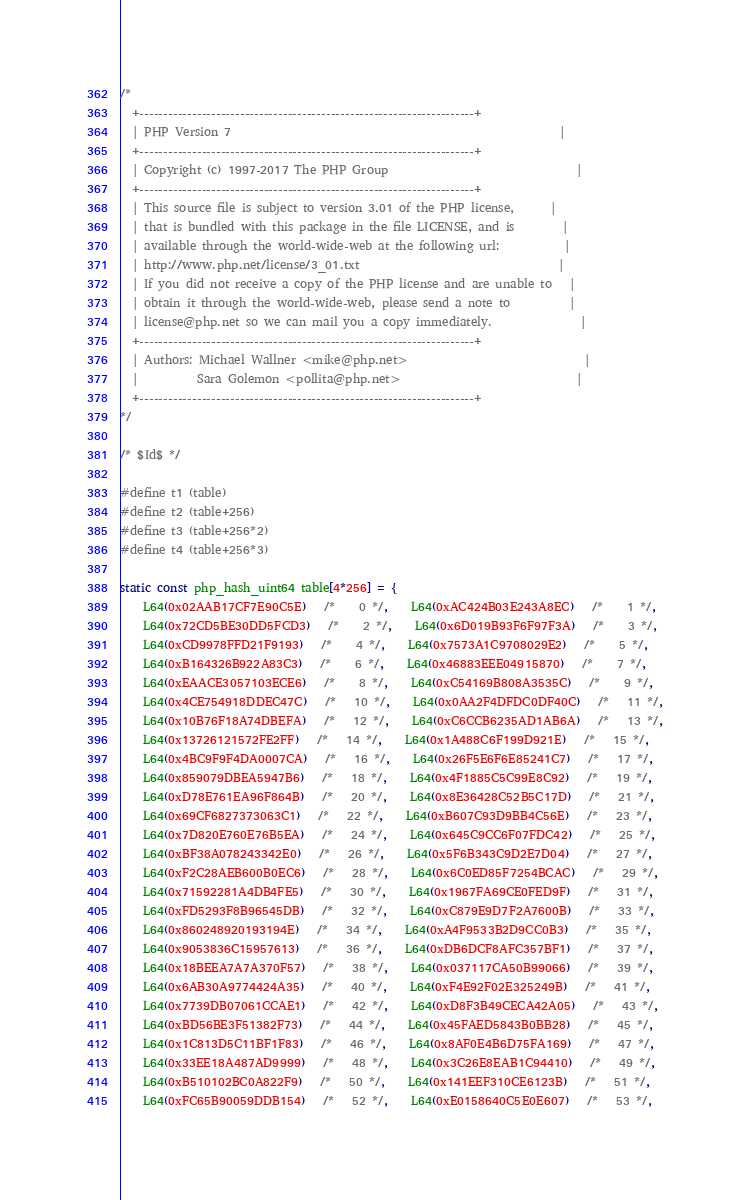Convert code to text. <code><loc_0><loc_0><loc_500><loc_500><_C_>/*
  +----------------------------------------------------------------------+
  | PHP Version 7                                                        |
  +----------------------------------------------------------------------+
  | Copyright (c) 1997-2017 The PHP Group                                |
  +----------------------------------------------------------------------+
  | This source file is subject to version 3.01 of the PHP license,      |
  | that is bundled with this package in the file LICENSE, and is        |
  | available through the world-wide-web at the following url:           |
  | http://www.php.net/license/3_01.txt                                  |
  | If you did not receive a copy of the PHP license and are unable to   |
  | obtain it through the world-wide-web, please send a note to          |
  | license@php.net so we can mail you a copy immediately.               |
  +----------------------------------------------------------------------+
  | Authors: Michael Wallner <mike@php.net>                              |
  |          Sara Golemon <pollita@php.net>                              |
  +----------------------------------------------------------------------+
*/

/* $Id$ */

#define t1 (table)
#define t2 (table+256)
#define t3 (table+256*2)
#define t4 (table+256*3)

static const php_hash_uint64 table[4*256] = {
	L64(0x02AAB17CF7E90C5E)   /*    0 */,    L64(0xAC424B03E243A8EC)   /*    1 */,
	L64(0x72CD5BE30DD5FCD3)   /*    2 */,    L64(0x6D019B93F6F97F3A)   /*    3 */,
	L64(0xCD9978FFD21F9193)   /*    4 */,    L64(0x7573A1C9708029E2)   /*    5 */,
	L64(0xB164326B922A83C3)   /*    6 */,    L64(0x46883EEE04915870)   /*    7 */,
	L64(0xEAACE3057103ECE6)   /*    8 */,    L64(0xC54169B808A3535C)   /*    9 */,
	L64(0x4CE754918DDEC47C)   /*   10 */,    L64(0x0AA2F4DFDC0DF40C)   /*   11 */,
	L64(0x10B76F18A74DBEFA)   /*   12 */,    L64(0xC6CCB6235AD1AB6A)   /*   13 */,
	L64(0x13726121572FE2FF)   /*   14 */,    L64(0x1A488C6F199D921E)   /*   15 */,
	L64(0x4BC9F9F4DA0007CA)   /*   16 */,    L64(0x26F5E6F6E85241C7)   /*   17 */,
	L64(0x859079DBEA5947B6)   /*   18 */,    L64(0x4F1885C5C99E8C92)   /*   19 */,
	L64(0xD78E761EA96F864B)   /*   20 */,    L64(0x8E36428C52B5C17D)   /*   21 */,
	L64(0x69CF6827373063C1)   /*   22 */,    L64(0xB607C93D9BB4C56E)   /*   23 */,
	L64(0x7D820E760E76B5EA)   /*   24 */,    L64(0x645C9CC6F07FDC42)   /*   25 */,
	L64(0xBF38A078243342E0)   /*   26 */,    L64(0x5F6B343C9D2E7D04)   /*   27 */,
	L64(0xF2C28AEB600B0EC6)   /*   28 */,    L64(0x6C0ED85F7254BCAC)   /*   29 */,
	L64(0x71592281A4DB4FE5)   /*   30 */,    L64(0x1967FA69CE0FED9F)   /*   31 */,
	L64(0xFD5293F8B96545DB)   /*   32 */,    L64(0xC879E9D7F2A7600B)   /*   33 */,
	L64(0x860248920193194E)   /*   34 */,    L64(0xA4F9533B2D9CC0B3)   /*   35 */,
	L64(0x9053836C15957613)   /*   36 */,    L64(0xDB6DCF8AFC357BF1)   /*   37 */,
	L64(0x18BEEA7A7A370F57)   /*   38 */,    L64(0x037117CA50B99066)   /*   39 */,
	L64(0x6AB30A9774424A35)   /*   40 */,    L64(0xF4E92F02E325249B)   /*   41 */,
	L64(0x7739DB07061CCAE1)   /*   42 */,    L64(0xD8F3B49CECA42A05)   /*   43 */,
	L64(0xBD56BE3F51382F73)   /*   44 */,    L64(0x45FAED5843B0BB28)   /*   45 */,
	L64(0x1C813D5C11BF1F83)   /*   46 */,    L64(0x8AF0E4B6D75FA169)   /*   47 */,
	L64(0x33EE18A487AD9999)   /*   48 */,    L64(0x3C26E8EAB1C94410)   /*   49 */,
	L64(0xB510102BC0A822F9)   /*   50 */,    L64(0x141EEF310CE6123B)   /*   51 */,
	L64(0xFC65B90059DDB154)   /*   52 */,    L64(0xE0158640C5E0E607)   /*   53 */,</code> 